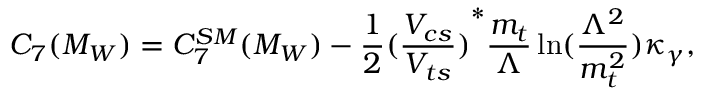<formula> <loc_0><loc_0><loc_500><loc_500>C _ { 7 } ( M _ { W } ) = C _ { 7 } ^ { S M } ( M _ { W } ) - \frac { 1 } { 2 } { ( \frac { V _ { c s } } { V _ { t s } } ) } ^ { * } \frac { m _ { t } } { \Lambda } \ln ( \frac { \Lambda ^ { 2 } } { m _ { t } ^ { 2 } } ) \kappa _ { \gamma } ,</formula> 